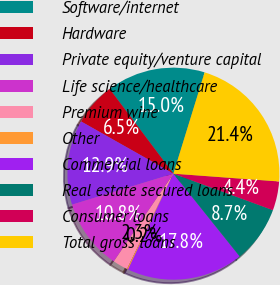Convert chart to OTSL. <chart><loc_0><loc_0><loc_500><loc_500><pie_chart><fcel>Software/internet<fcel>Hardware<fcel>Private equity/venture capital<fcel>Life science/healthcare<fcel>Premium wine<fcel>Other<fcel>Commercial loans<fcel>Real estate secured loans<fcel>Consumer loans<fcel>Total gross loans<nl><fcel>15.03%<fcel>6.54%<fcel>12.91%<fcel>10.79%<fcel>2.29%<fcel>0.17%<fcel>17.78%<fcel>8.66%<fcel>4.42%<fcel>21.41%<nl></chart> 